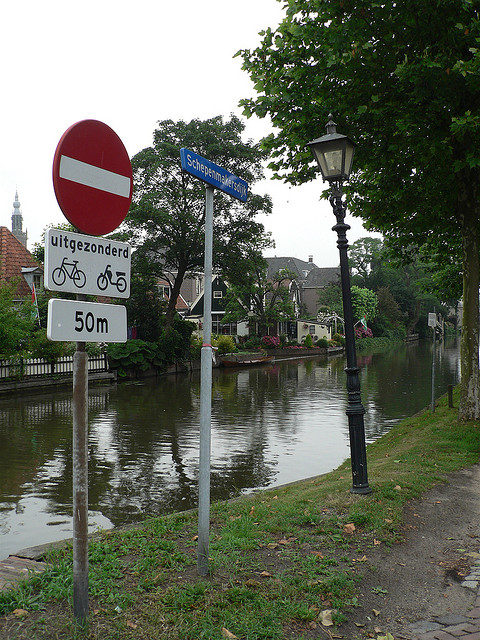Extract all visible text content from this image. uitgezonderd 50M 